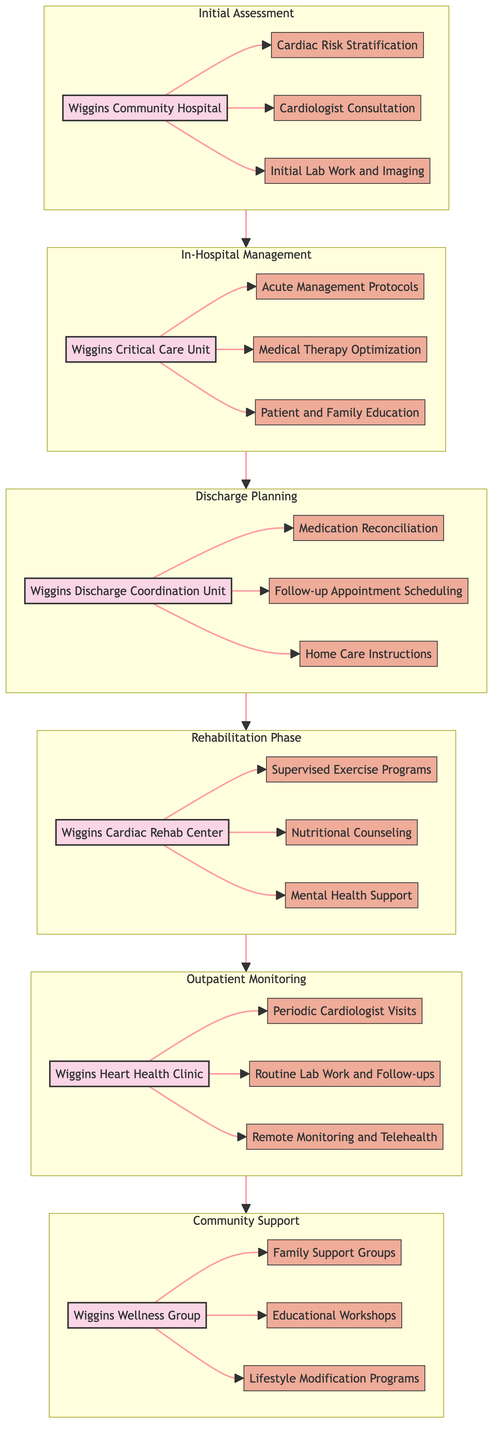What's the first entity in the Clinical Pathway? The diagram shows "Wiggins Community Hospital" as the first entity in the Initial Assessment section, indicating where the process begins.
Answer: Wiggins Community Hospital How many components are in the In-Hospital Management phase? In the In-Hospital Management section, there are three components: Acute Management Protocols, Medical Therapy Optimization, and Patient and Family Education.
Answer: 3 Which unit is responsible for Discharge Planning? The Discharge Planning section lists "Wiggins Discharge Coordination Unit" as the entity, indicating its responsibility for planning the patient's discharge process.
Answer: Wiggins Discharge Coordination Unit What follows the Rehabilitation Phase in the Clinical Pathway? The flow in the diagram shows that the phase following Rehabilitation Phase is Outpatient Monitoring, indicating the next step for patients after rehabilitation.
Answer: Outpatient Monitoring What types of support groups are available in Community Support? The Community Support section includes "Family Support Groups" as one of the components offered, indicating emotional and social support for patients and their families.
Answer: Family Support Groups How many entities are involved in the entire Clinical Pathway? By counting the entities in each section of the diagram (Initial Assessment, In-Hospital Management, Discharge Planning, Rehabilitation Phase, Outpatient Monitoring, Community Support), we find there are six distinct entities.
Answer: 6 What is included in the Outpatient Monitoring phase? Outpatient Monitoring comprises three components: Periodic Cardiologist Visits, Routine Lab Work and Follow-ups, and Remote Monitoring and Telehealth, which help in ongoing patient care.
Answer: Periodic Cardiologist Visits, Routine Lab Work and Follow-ups, Remote Monitoring and Telehealth What is the main purpose of the Wiggins Cardiac Rehab Center? The Wiggins Cardiac Rehab Center focuses on providing rehabilitation through components such as Supervised Exercise Programs, Nutritional Counseling, and Mental Health Support, which are critical for recovery.
Answer: Rehabilitation What type of education is provided in the In-Hospital Management section? Within the In-Hospital Management section, "Patient and Family Education" is a key component designed to inform both patients and their family members about care and management of heart health.
Answer: Patient and Family Education 